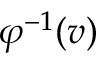<formula> <loc_0><loc_0><loc_500><loc_500>\varphi ^ { - 1 } ( v )</formula> 